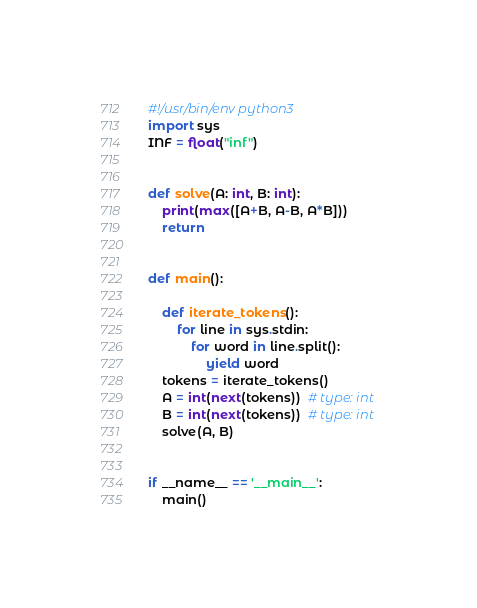<code> <loc_0><loc_0><loc_500><loc_500><_Python_>#!/usr/bin/env python3
import sys
INF = float("inf")


def solve(A: int, B: int):
    print(max([A+B, A-B, A*B]))
    return


def main():

    def iterate_tokens():
        for line in sys.stdin:
            for word in line.split():
                yield word
    tokens = iterate_tokens()
    A = int(next(tokens))  # type: int
    B = int(next(tokens))  # type: int
    solve(A, B)


if __name__ == '__main__':
    main()
</code> 